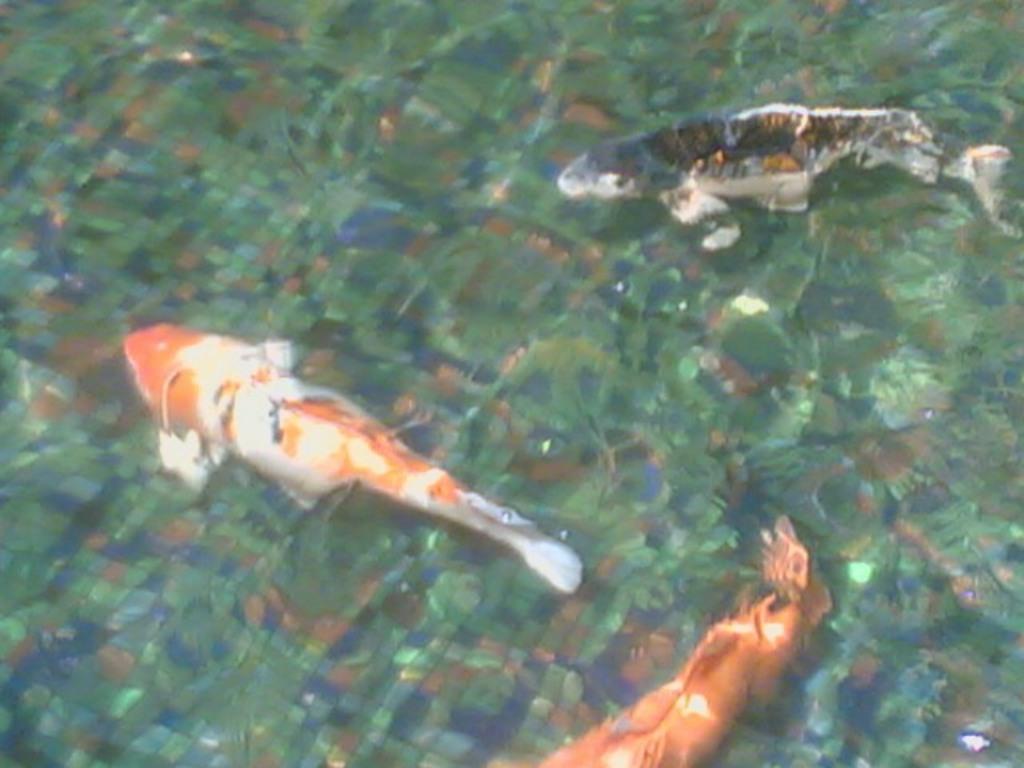In one or two sentences, can you explain what this image depicts? In this image there are three fisheś in the water. 